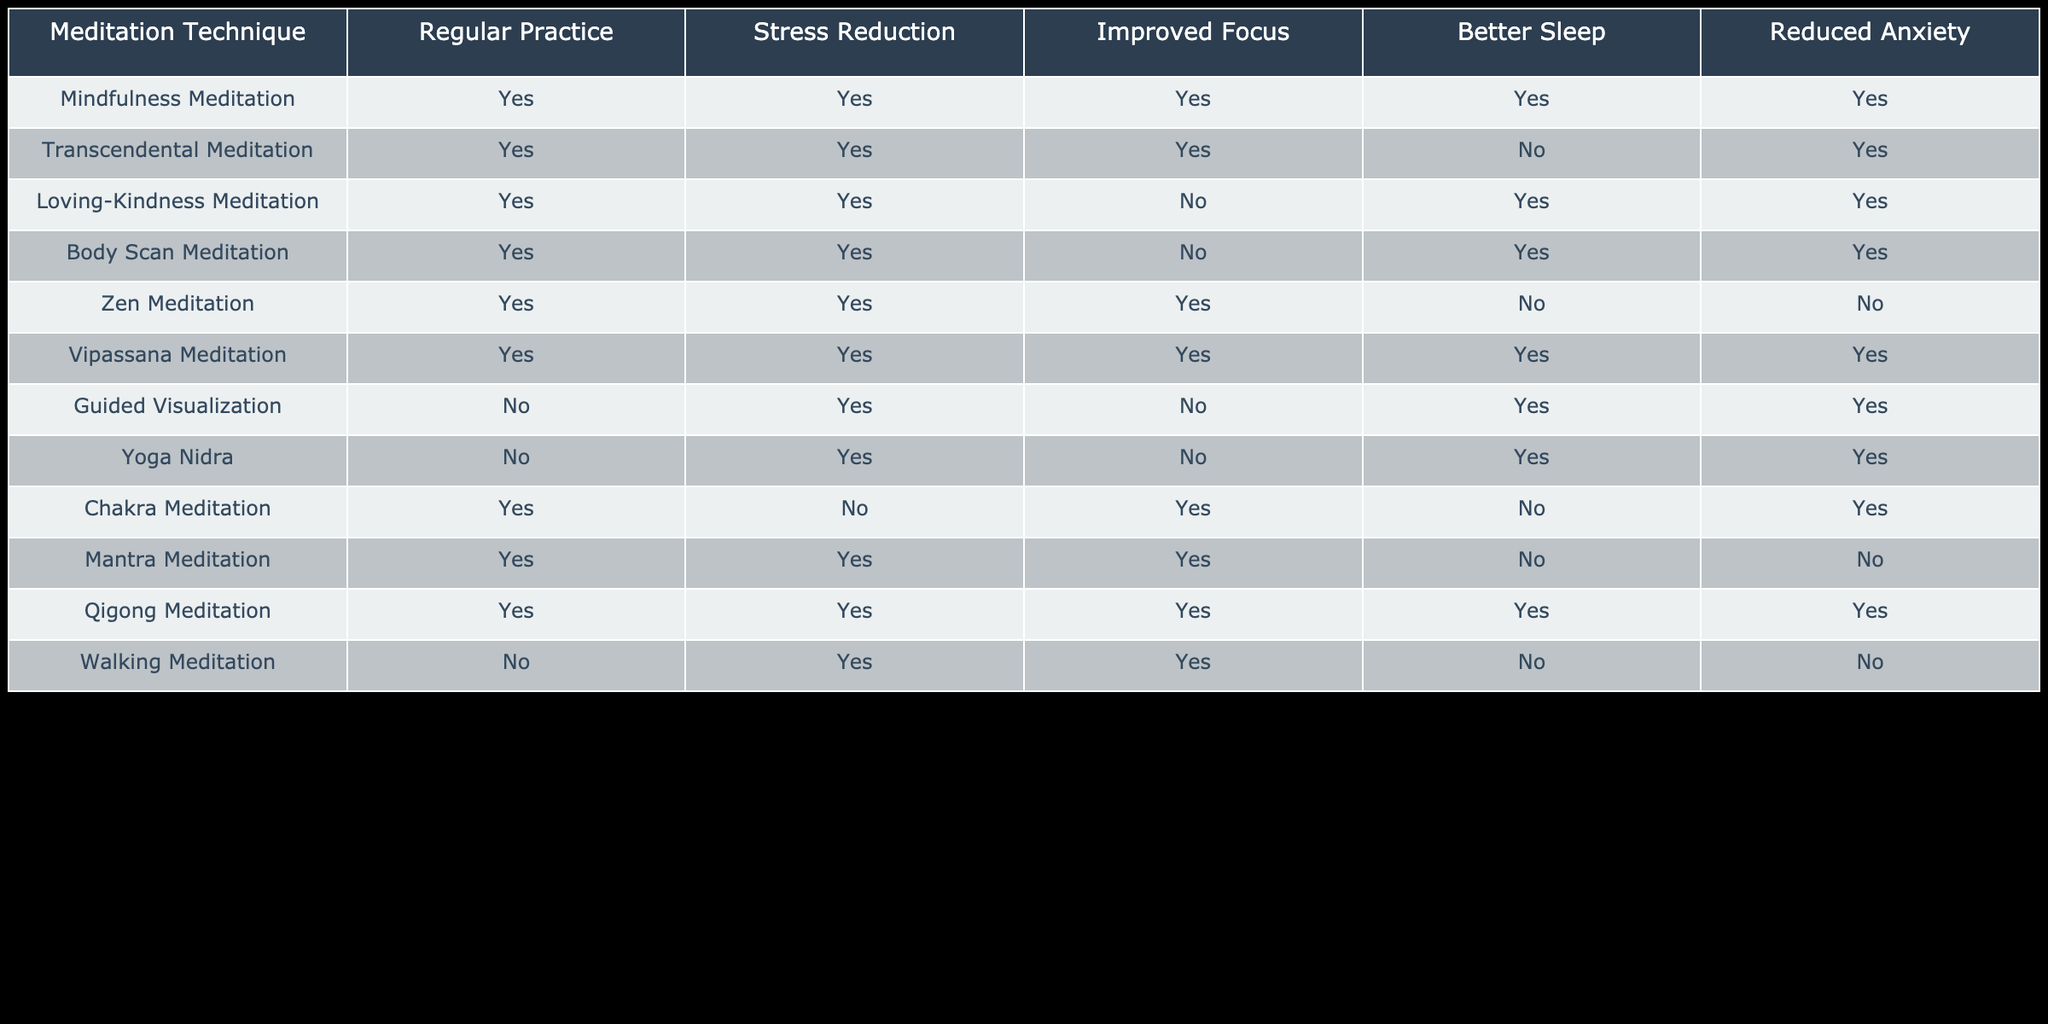What meditation techniques show improved focus? By scanning the table, we look at the column labeled "Improved Focus" and find which techniques have a TRUE value. These techniques are Mindfulness Meditation, Transcendental Meditation, Zen Meditation, Vipassana Meditation, Mantra Meditation, and Qigong Meditation.
Answer: Mindfulness Meditation, Transcendental Meditation, Zen Meditation, Vipassana Meditation, Mantra Meditation, Qigong Meditation Is there any meditation technique that reduces anxiety but does not improve sleep? To answer this, we should examine the "Reduced Anxiety" and "Better Sleep" columns. The Loving-Kindness Meditation, Body Scan Meditation, and Chakra Meditation reduce anxiety, while only Chakra Meditation does not improve sleep (FALSE).
Answer: Chakra Meditation How many meditation techniques have regular practice and do not reduce stress? We check the "Regular Practice" and "Stress Reduction" columns. There is only one technique, Chakra Meditation, marked with TRUE for Regular Practice and FALSE for Stress Reduction. Thus, the count is 1.
Answer: 1 Which meditation techniques do not require regular practice but still contribute to stress reduction? By looking at the "Regular Practice" column with FALSE values, we find Guided Visualization and Yoga Nidra both contribute to stress reduction (TRUE under "Stress Reduction"). This gives a total of two techniques.
Answer: 2 Which meditation techniques improve sleep but do not reduce anxiety? In the "Better Sleep" column, we identify techniques that have TRUE under improved sleep and FALSE under reduced anxiety. This is true for both Transcendental Meditation and Body Scan Meditation.
Answer: Transcendental Meditation, Body Scan Meditation 